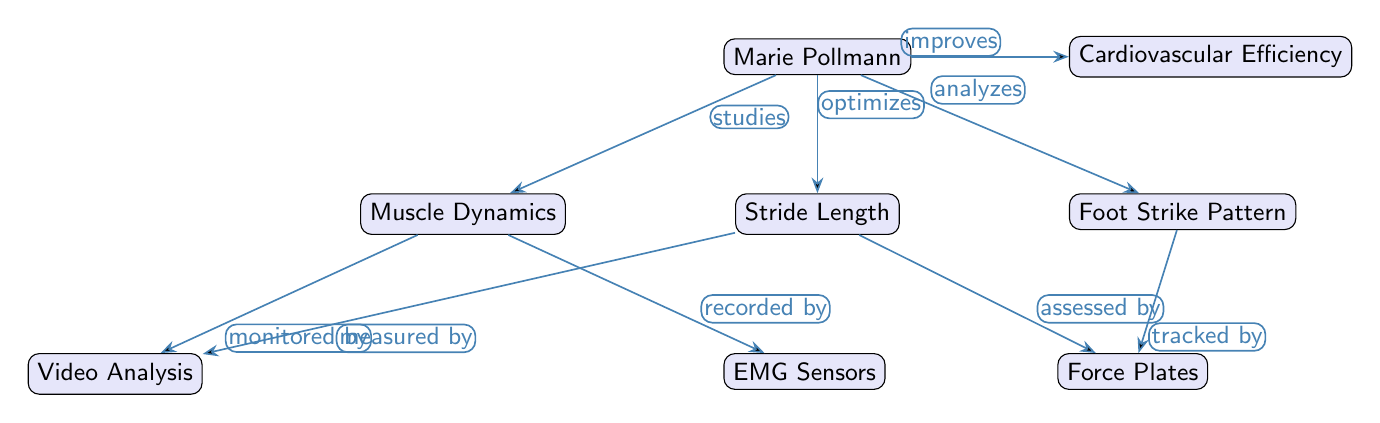What is the central node in the diagram? The central node in the diagram is Marie Pollmann, which is directly connected to four other nodes representing different aspects of biomechanical analysis.
Answer: Marie Pollmann How many edges are connected to the "Stride Length" node? The "Stride Length" node has two edges: one connecting it to the "Video Analysis" node and another to the "Force Plates" node, indicating its relationship with these aspects.
Answer: 2 What aspect is monitored by "Video Analysis"? The node "Muscle Dynamics" and "Stride Length" both indicate that "Video Analysis" monitors these aspects of Marie Pollmann's performance in running.
Answer: Muscle Dynamics, Stride Length Which node is related to cardiovascular performance? The node "Cardiovascular Efficiency" is related to Marie Pollmann’s running performance, indicating an optimization aspect in the analysis.
Answer: Cardiovascular Efficiency What type of data is recorded by "EMG Sensors"? The "EMG Sensors" are associated with the "Muscle Dynamics" node, meaning they record electrical activity from the muscles during running analysis.
Answer: Muscle Dynamics What does Marie Pollmann optimize in her training? According to the diagram, Marie Pollmann optimizes her "Stride Length" as a critical component of her running technique.
Answer: Stride Length Which nodes are assessed by "Force Plates"? The "Stride Length" and "Foot Strike Pattern" nodes are assessed by "Force Plates," indicating that these two aspects are measured for their performance qualities.
Answer: Stride Length, Foot Strike Pattern How does "Muscle Dynamics" relate to "Video Analysis"? "Muscle Dynamics" is monitored by "Video Analysis," showing the connection between visual footage and understanding muscle behavior during running.
Answer: Monitored by What studies does Marie Pollmann conduct on her technique? She conducts studies on "Muscle Dynamics," "Stride Length," "Foot Strike Pattern," and "Cardiovascular Efficiency" to enhance her running performance.
Answer: Muscle Dynamics, Stride Length, Foot Strike Pattern, Cardiovascular Efficiency 